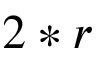<formula> <loc_0><loc_0><loc_500><loc_500>2 * r</formula> 